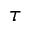<formula> <loc_0><loc_0><loc_500><loc_500>\tau</formula> 